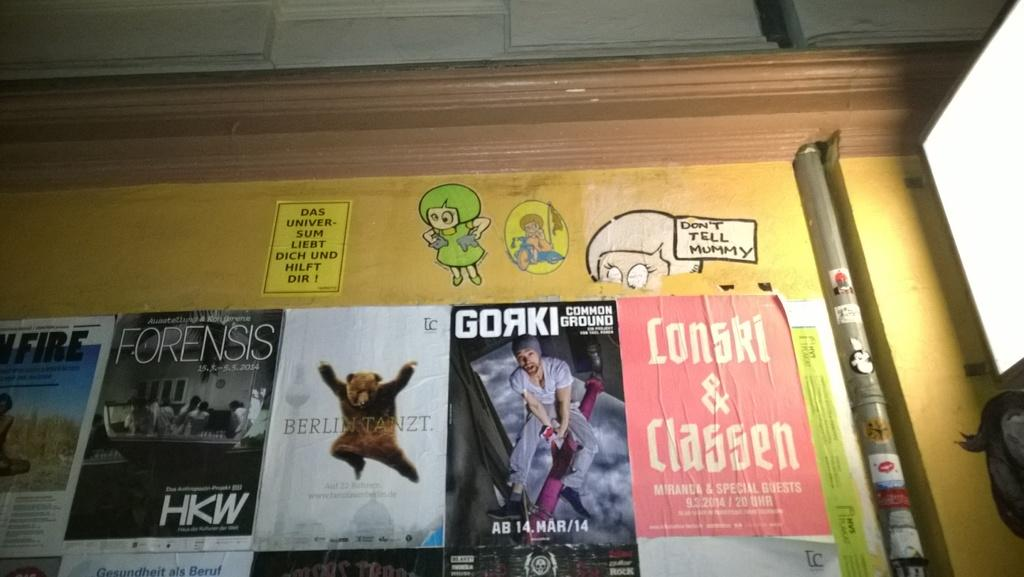<image>
Write a terse but informative summary of the picture. Someone ha put a sticker that says "don't tell mummy" on this wall. 